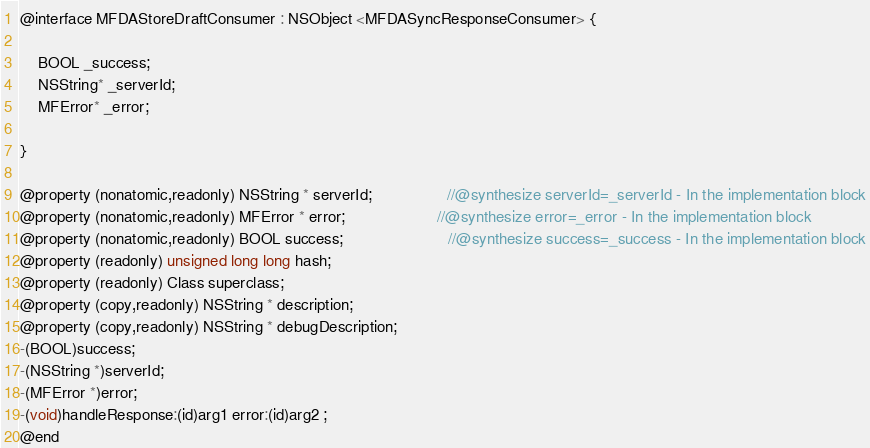<code> <loc_0><loc_0><loc_500><loc_500><_C_>
@interface MFDAStoreDraftConsumer : NSObject <MFDASyncResponseConsumer> {

	BOOL _success;
	NSString* _serverId;
	MFError* _error;

}

@property (nonatomic,readonly) NSString * serverId;                 //@synthesize serverId=_serverId - In the implementation block
@property (nonatomic,readonly) MFError * error;                     //@synthesize error=_error - In the implementation block
@property (nonatomic,readonly) BOOL success;                        //@synthesize success=_success - In the implementation block
@property (readonly) unsigned long long hash; 
@property (readonly) Class superclass; 
@property (copy,readonly) NSString * description; 
@property (copy,readonly) NSString * debugDescription; 
-(BOOL)success;
-(NSString *)serverId;
-(MFError *)error;
-(void)handleResponse:(id)arg1 error:(id)arg2 ;
@end

</code> 